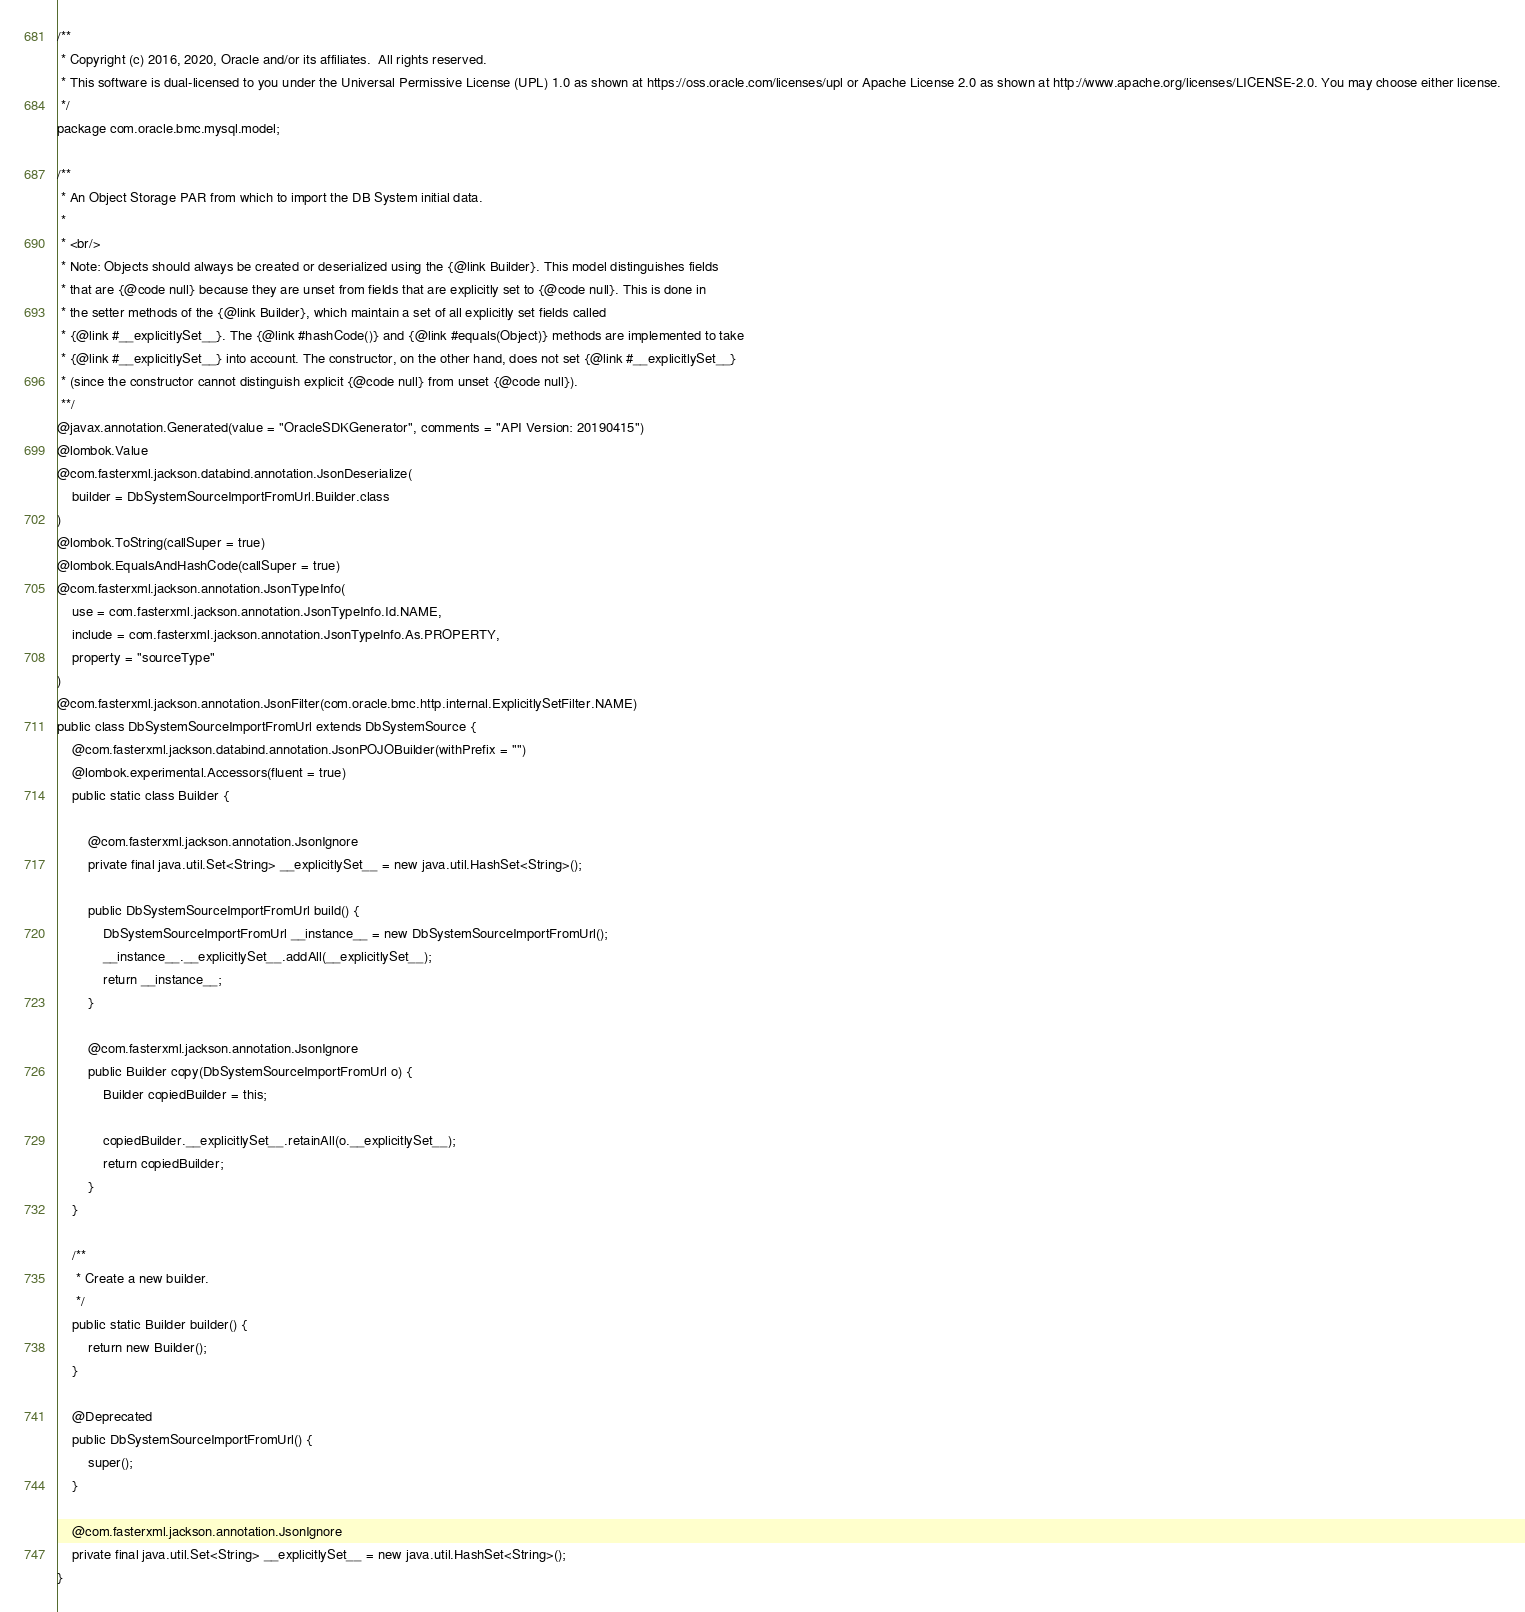<code> <loc_0><loc_0><loc_500><loc_500><_Java_>/**
 * Copyright (c) 2016, 2020, Oracle and/or its affiliates.  All rights reserved.
 * This software is dual-licensed to you under the Universal Permissive License (UPL) 1.0 as shown at https://oss.oracle.com/licenses/upl or Apache License 2.0 as shown at http://www.apache.org/licenses/LICENSE-2.0. You may choose either license.
 */
package com.oracle.bmc.mysql.model;

/**
 * An Object Storage PAR from which to import the DB System initial data.
 *
 * <br/>
 * Note: Objects should always be created or deserialized using the {@link Builder}. This model distinguishes fields
 * that are {@code null} because they are unset from fields that are explicitly set to {@code null}. This is done in
 * the setter methods of the {@link Builder}, which maintain a set of all explicitly set fields called
 * {@link #__explicitlySet__}. The {@link #hashCode()} and {@link #equals(Object)} methods are implemented to take
 * {@link #__explicitlySet__} into account. The constructor, on the other hand, does not set {@link #__explicitlySet__}
 * (since the constructor cannot distinguish explicit {@code null} from unset {@code null}).
 **/
@javax.annotation.Generated(value = "OracleSDKGenerator", comments = "API Version: 20190415")
@lombok.Value
@com.fasterxml.jackson.databind.annotation.JsonDeserialize(
    builder = DbSystemSourceImportFromUrl.Builder.class
)
@lombok.ToString(callSuper = true)
@lombok.EqualsAndHashCode(callSuper = true)
@com.fasterxml.jackson.annotation.JsonTypeInfo(
    use = com.fasterxml.jackson.annotation.JsonTypeInfo.Id.NAME,
    include = com.fasterxml.jackson.annotation.JsonTypeInfo.As.PROPERTY,
    property = "sourceType"
)
@com.fasterxml.jackson.annotation.JsonFilter(com.oracle.bmc.http.internal.ExplicitlySetFilter.NAME)
public class DbSystemSourceImportFromUrl extends DbSystemSource {
    @com.fasterxml.jackson.databind.annotation.JsonPOJOBuilder(withPrefix = "")
    @lombok.experimental.Accessors(fluent = true)
    public static class Builder {

        @com.fasterxml.jackson.annotation.JsonIgnore
        private final java.util.Set<String> __explicitlySet__ = new java.util.HashSet<String>();

        public DbSystemSourceImportFromUrl build() {
            DbSystemSourceImportFromUrl __instance__ = new DbSystemSourceImportFromUrl();
            __instance__.__explicitlySet__.addAll(__explicitlySet__);
            return __instance__;
        }

        @com.fasterxml.jackson.annotation.JsonIgnore
        public Builder copy(DbSystemSourceImportFromUrl o) {
            Builder copiedBuilder = this;

            copiedBuilder.__explicitlySet__.retainAll(o.__explicitlySet__);
            return copiedBuilder;
        }
    }

    /**
     * Create a new builder.
     */
    public static Builder builder() {
        return new Builder();
    }

    @Deprecated
    public DbSystemSourceImportFromUrl() {
        super();
    }

    @com.fasterxml.jackson.annotation.JsonIgnore
    private final java.util.Set<String> __explicitlySet__ = new java.util.HashSet<String>();
}
</code> 